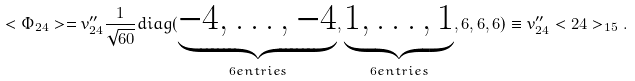Convert formula to latex. <formula><loc_0><loc_0><loc_500><loc_500>< \Phi _ { 2 4 } > = v ^ { \prime \prime } _ { 2 4 } \frac { 1 } { \sqrt { 6 0 } } d i a g ( \underbrace { - 4 , \dots , - 4 } _ { 6 e n t r i e s } , \underbrace { 1 , \dots , 1 } _ { 6 e n t r i e s } , 6 , 6 , 6 ) \equiv v ^ { \prime \prime } _ { 2 4 } < 2 4 > _ { 1 5 } .</formula> 